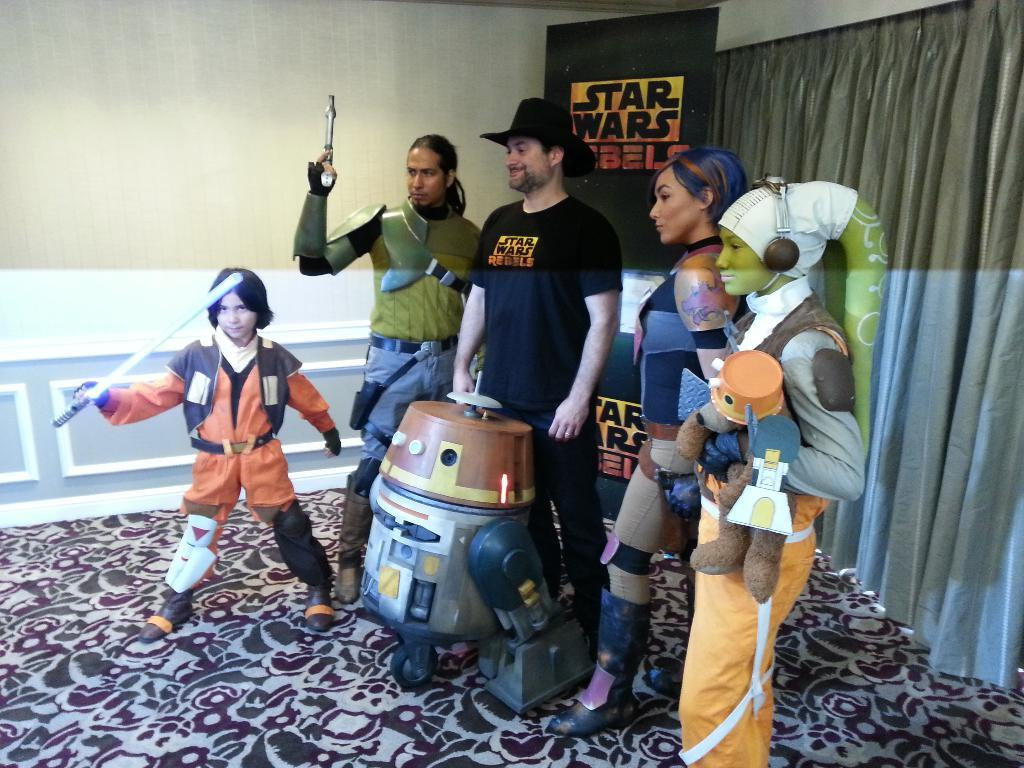What are the people in the center of the image doing? The people in the center of the image are wearing different costumes, which suggests they might be participating in a performance or event. What can be seen on the right side of the image? There is a curtain and a well on the right side of the image. What is visible in the background of the image? There is a banner in the center background of the image. What type of spark can be seen coming from the flesh of the people in the image? There is no spark or flesh visible in the image; the people are wearing costumes and there is no indication of any sparks or injuries. 